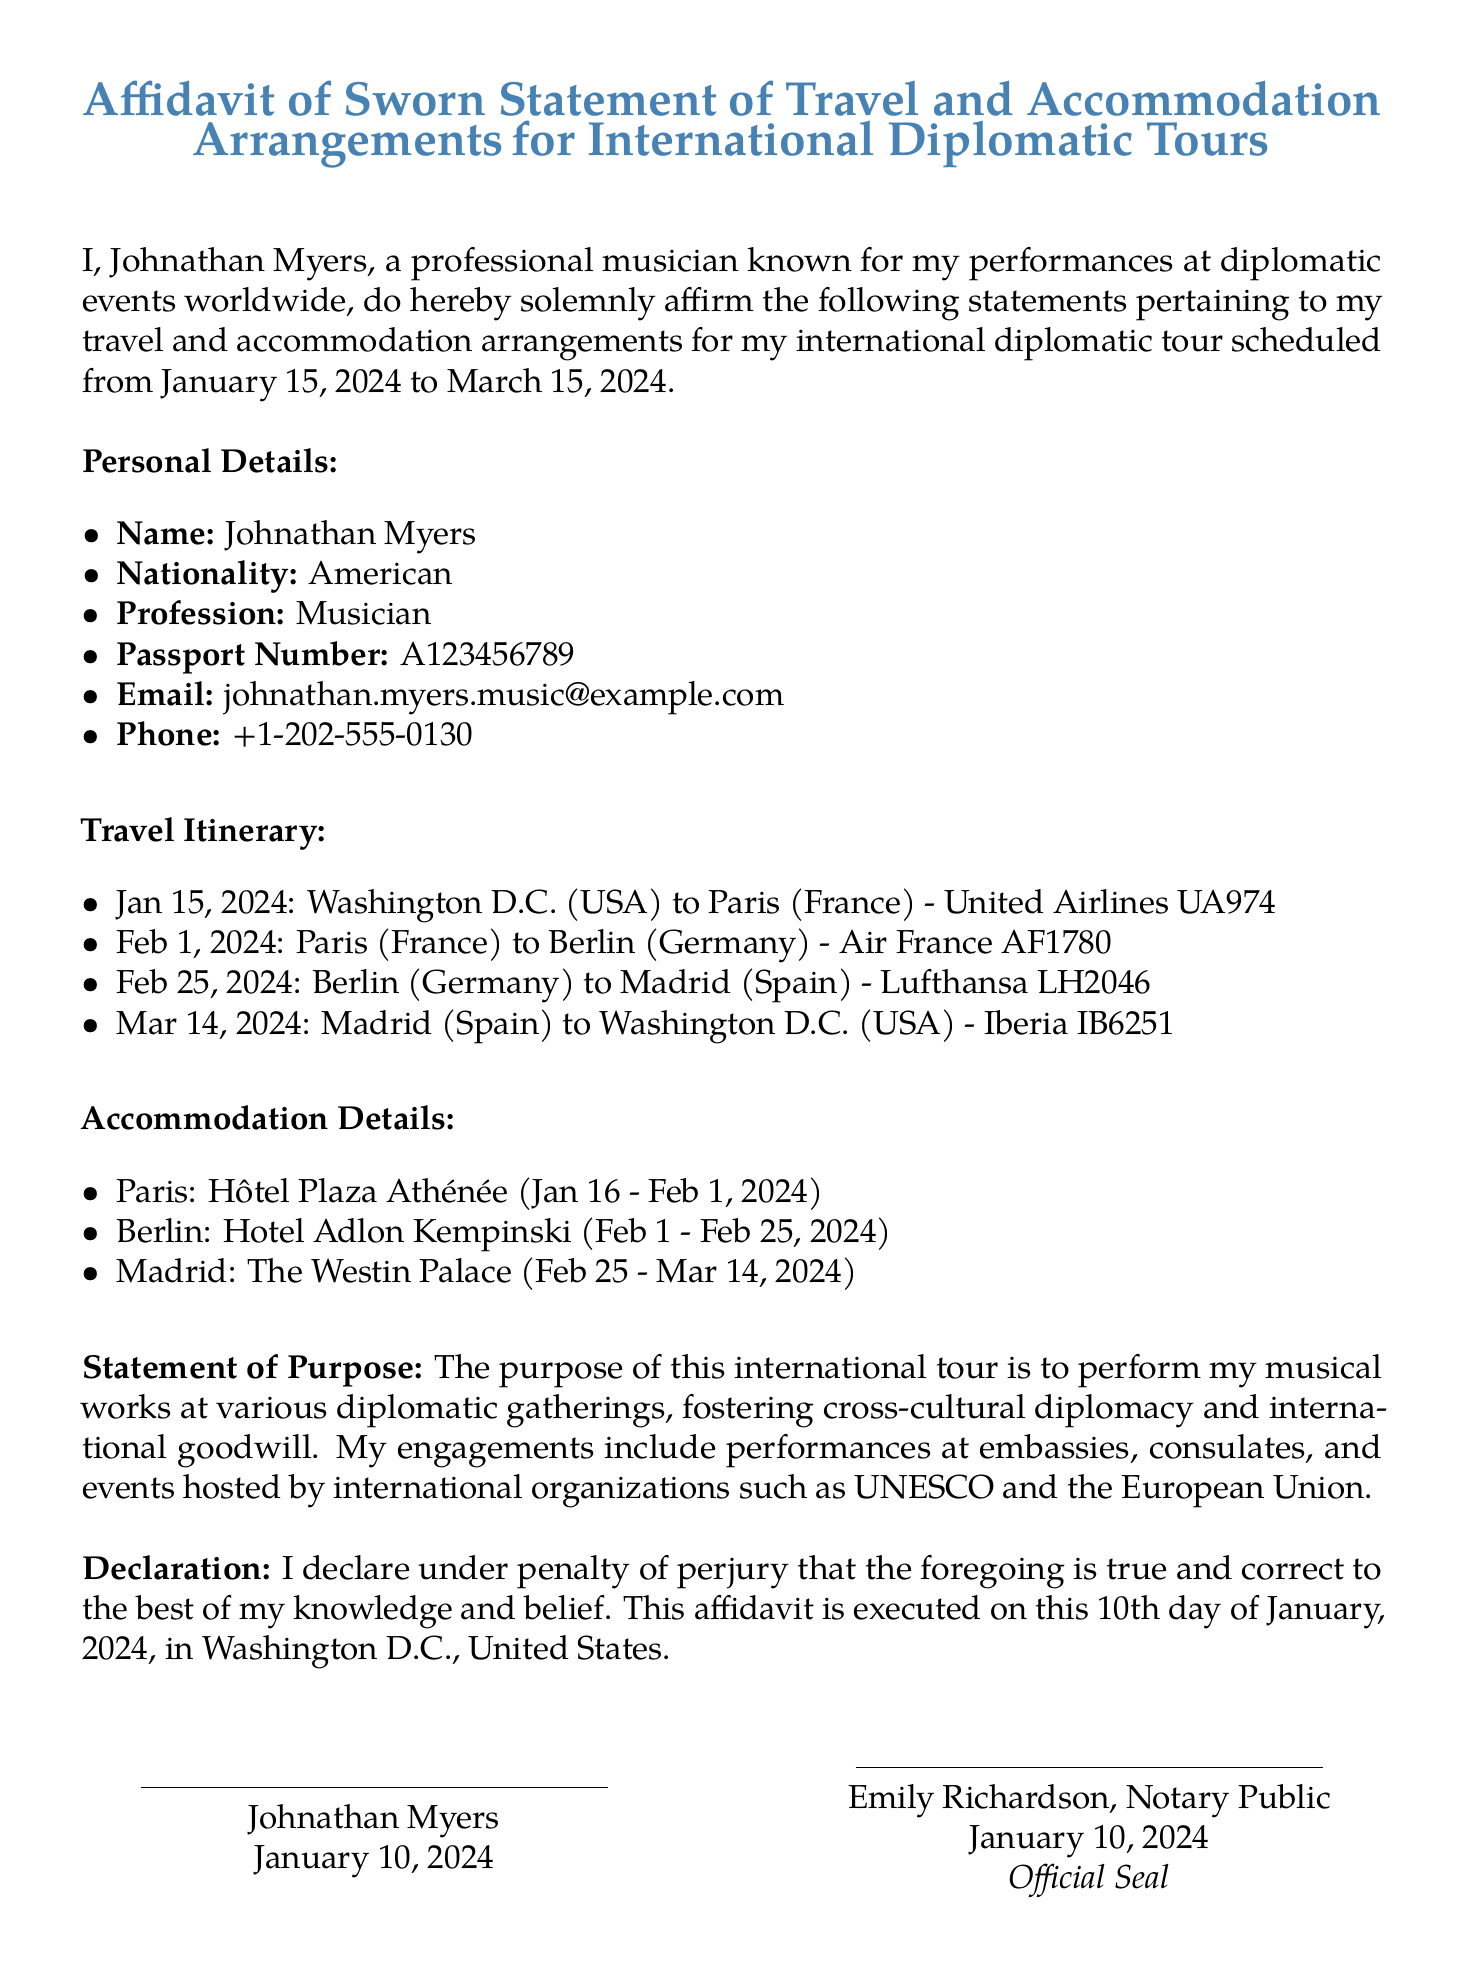What is the full name of the affiant? The affiant's full name is identified in the document as the person making the sworn statement, which is Johnathan Myers.
Answer: Johnathan Myers What is the nationality of the affiant? The nationality indicates the country of citizenship of the affiant, which in this case is noted as American.
Answer: American What is the purpose of the international tour? The purpose summarizes the main objective of the travel, which is to perform musical works at various diplomatic gatherings.
Answer: Perform musical works What are the travel dates for the tour? The travel dates signify the start and end of the travel itinerary, which are January 15, 2024 to March 15, 2024.
Answer: January 15, 2024 to March 15, 2024 What hotel will the affiant stay in Madrid? The hotel name in the accommodation section specifies where the affiant will be staying in Madrid, which is The Westin Palace.
Answer: The Westin Palace How many flights are mentioned in the travel itinerary? The flights listed indicate the total modes of travel the affiant will undertake, which counts to four flights.
Answer: Four Who is the notary public that signed the affidavit? The name of the notary public is provided in the document to validate the statement, which is Emily Richardson.
Answer: Emily Richardson On what date was the affidavit executed? The date of execution refers to when the affidavit was formally completed, which is stated as January 10, 2024.
Answer: January 10, 2024 